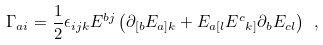Convert formula to latex. <formula><loc_0><loc_0><loc_500><loc_500>\Gamma _ { a i } = \frac { 1 } { 2 } \epsilon _ { i j k } E ^ { b j } \left ( \partial _ { [ b } E _ { a ] k } + E _ { a [ l } E ^ { c } { _ { k ] } } \partial _ { b } E _ { c l } \right ) \ ,</formula> 